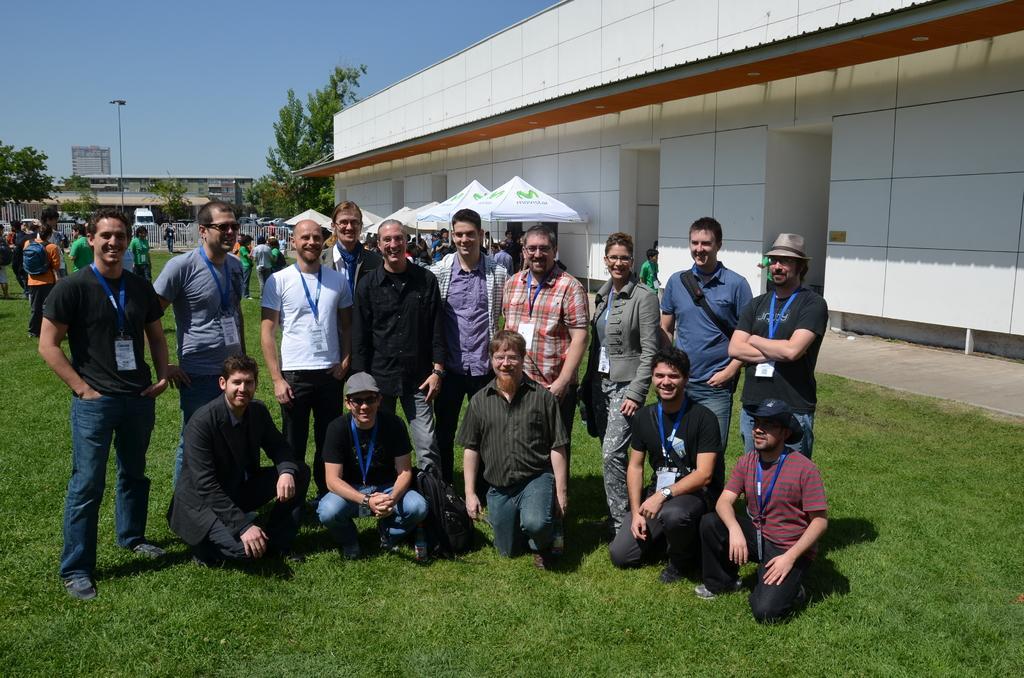How would you summarize this image in a sentence or two? In this image there are a few people sitting on their knees, few are standing with a smile on their face, behind them there are a few people standing and walking on the surface of the grass. On the right side of the image there is a building, in front of the building there are stalls. In the background there are trees, buildings and the sky. 